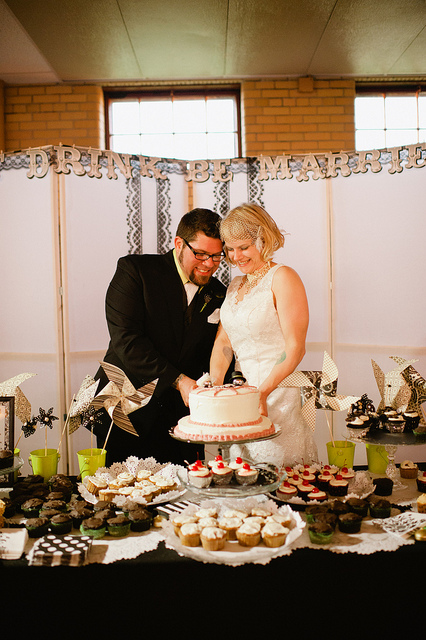Describe the type of desserts on the table apart from the cake. Besides the cake, the table presents a variety of treats including cupcakes topped with white and dark frosting, some garnished with red berries. There are also muffin-like desserts in individual cups, possibly suggesting a choice of flavors for the guests. What do the expressions of the individuals suggest about the moment captured in this photograph? The expressions of the individual couple suggest joy and contentment. Their smiles and close proximity to each other, coupled with the intimate gesture of cutting the cake together, convey a sense of shared happiness and celebration on their special day. 